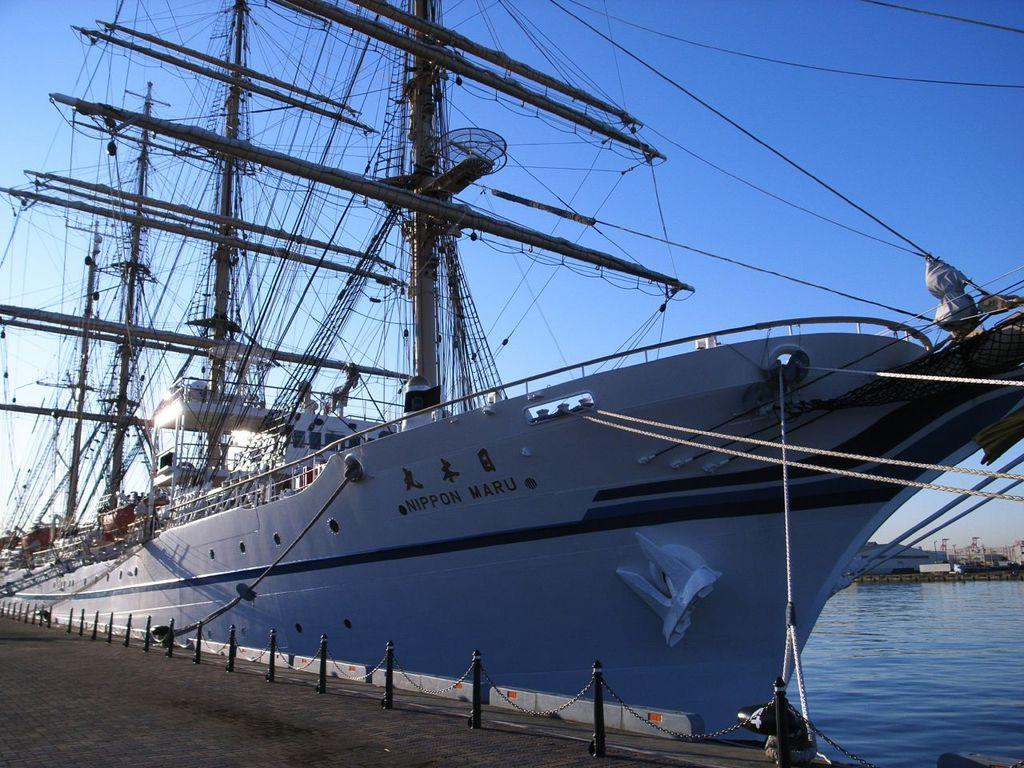What is the main subject of the image? The main subject of the image is a ship. Where is the ship located in the image? The ship is on the water in the image. What other objects can be seen in the image? There are poles and ropes visible in the image. What can be seen in the background of the image? The sky is visible in the background of the image. What type of grass is growing on the ship in the image? There is no grass visible on the ship in the image. 